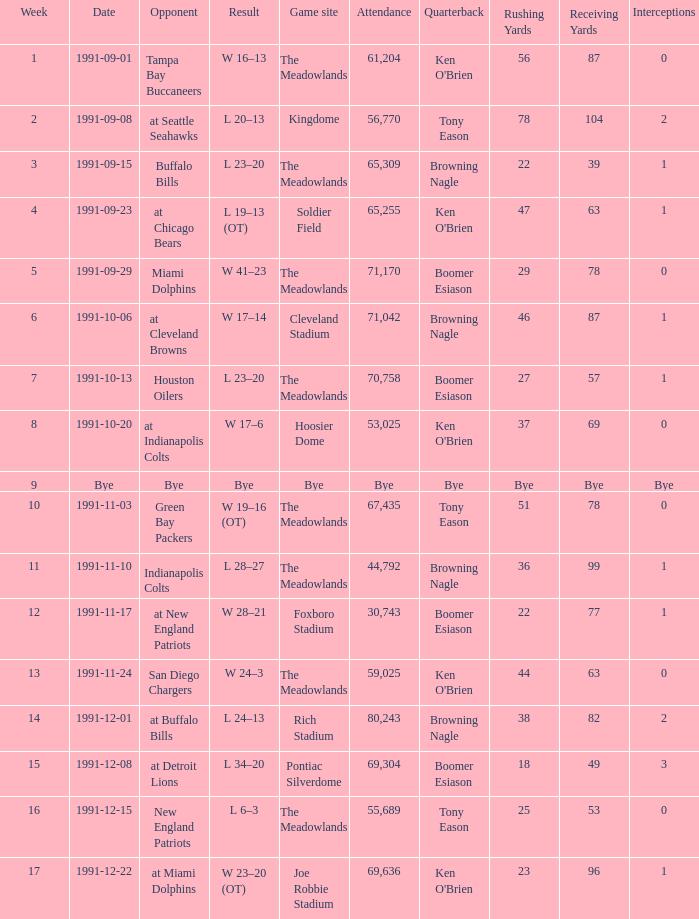What was the number of attendees at the game held at hoosier dome? 53025.0. 